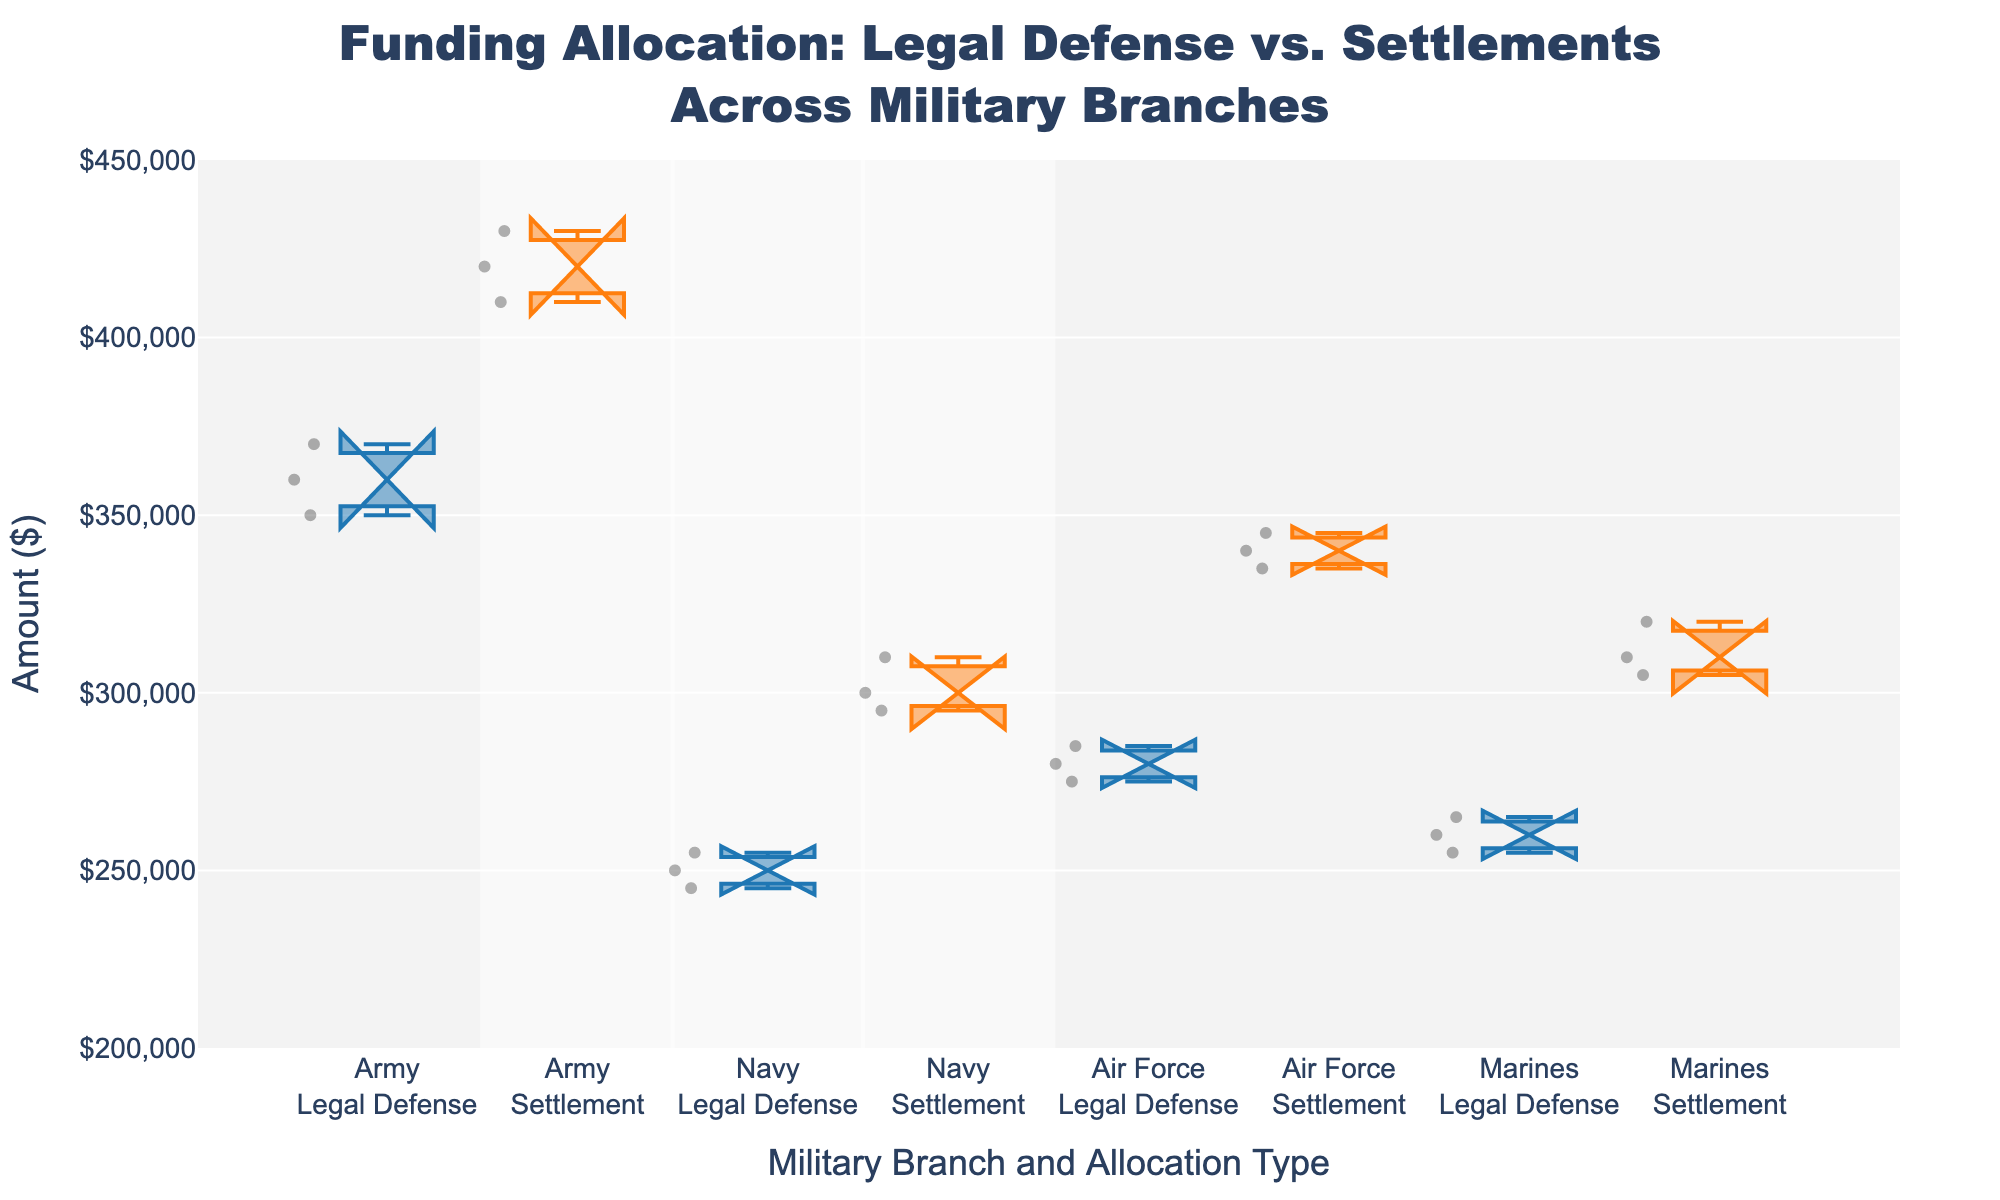What is the title of the figure? The title is prominently displayed at the top of the figure.
Answer: Funding Allocation: Legal Defense vs. Settlements Across Military Branches How many branches are represented in the plot? Each branch is represented by two box plots (Legal Defense and Settlement) across the x-axis, which can be counted to determine the total number.
Answer: Four Which branch has the highest median funding for Settlements? The box plots' notches represent the median for each branch and type. Look for the highest notch among the Settlement categories.
Answer: Army What is the range of the y-axis in the figure? The y-axis range is indicated by the ticks and labels on the y-axis, showing the minimum and maximum values.
Answer: $200,000 to $450,000 How does the median amount of Legal Defense for the Air Force compare to that of the Navy? Compare the notches representing the median values for Air Force and Navy in the Legal Defense category.
Answer: Higher for Air Force What is the interquartile range (IQR) of Settlement funding for the Marines? The IQR is the difference between the upper quartile (Q3) and lower quartile (Q1). Visually determine these from the Marines' Settlement box plot.
Answer: $315,000 - $305,000 = $10,000 Are there any outliers in the Army's Legal Defense funding? Outliers are typically indicated by individual points outside the whiskers of a box plot. Check the Army's Legal Defense box plot for such points.
Answer: No Which branch has the narrowest notch for Legal Defense, indicating a more precise median estimate? The width of the notch represents the uncertainty around the median. Find the narrowest notch among the Legal Defense categories.
Answer: Marines Comparing the upper quartile (Q3) values of Legal Defense, which branch has the highest value? Identify the top edge of the boxes for Legal Defense across all branches and see which is the highest.
Answer: Army Is the distribution of Settlement funding for the Navy more symmetric compared to the other branches? Symmetry can be assessed by the shape and spread of the box plot in relation to its median. Examine if the Navy's Settlement box plot appears more symmetric.
Answer: Yes 